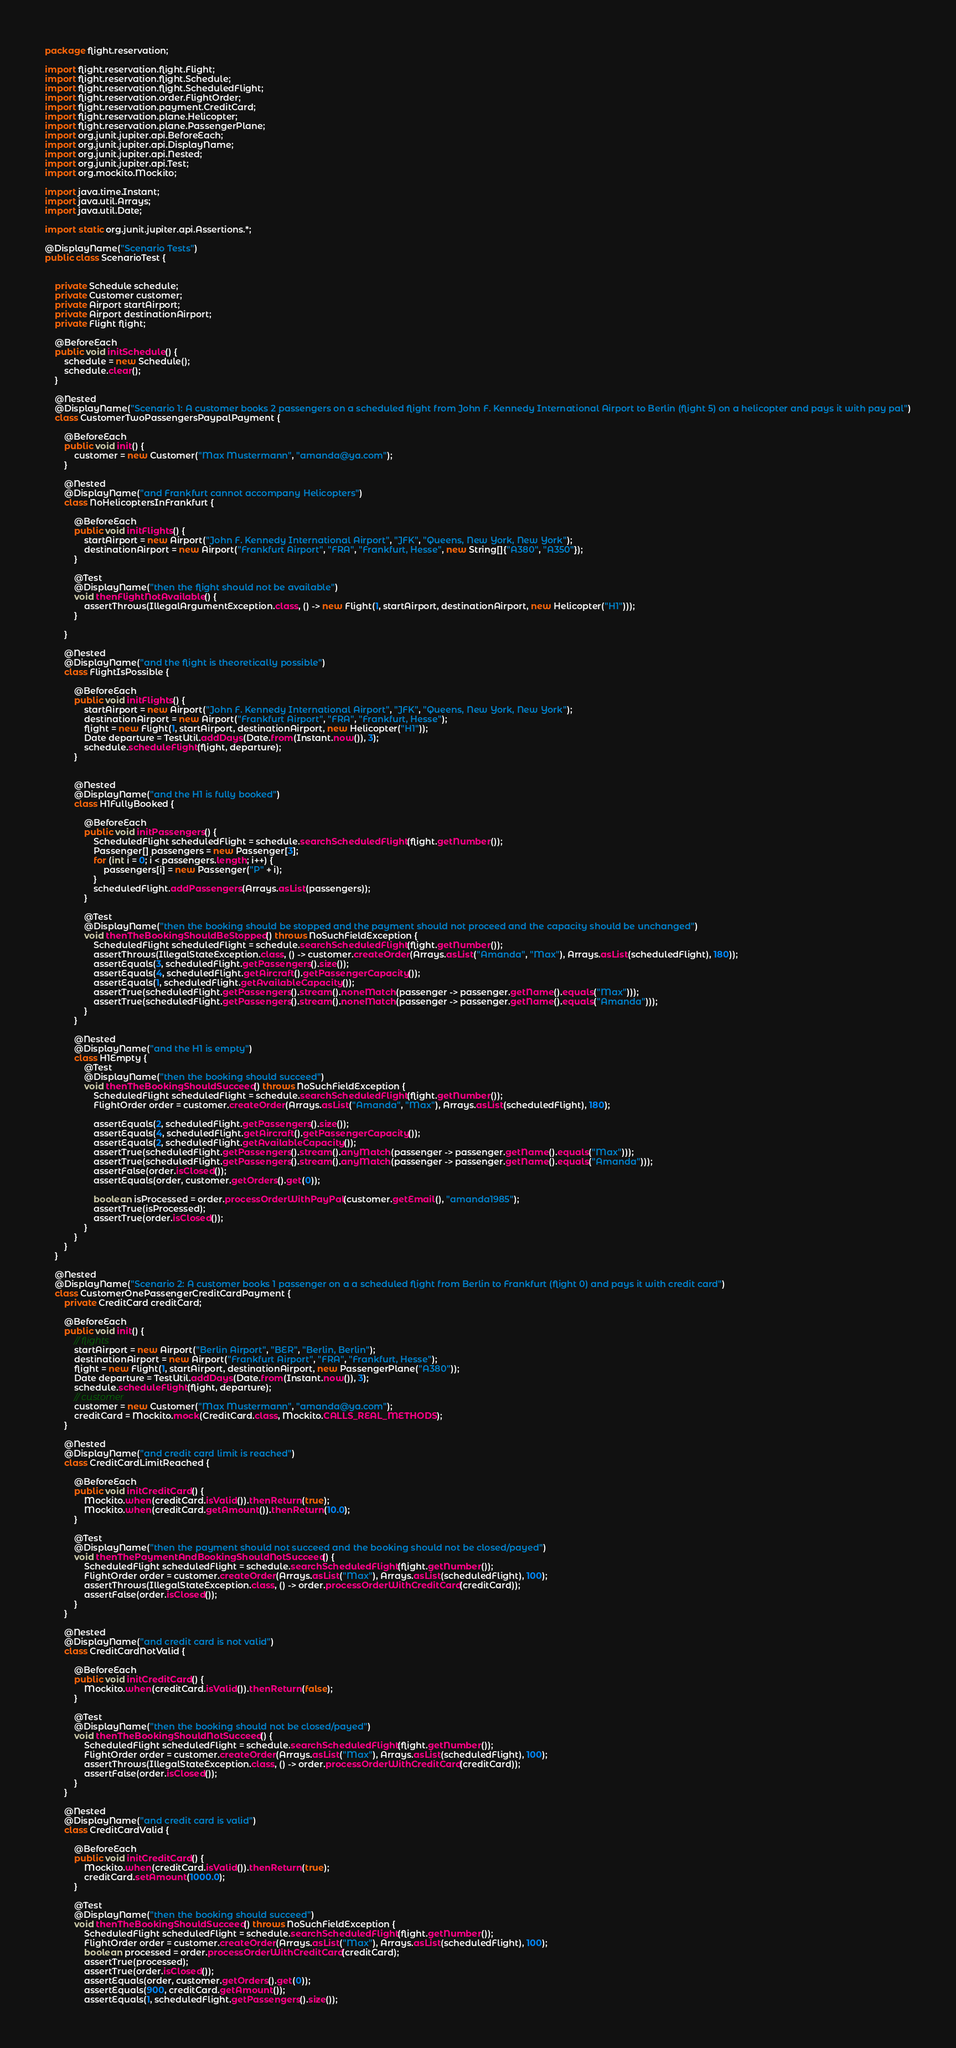<code> <loc_0><loc_0><loc_500><loc_500><_Java_>package flight.reservation;

import flight.reservation.flight.Flight;
import flight.reservation.flight.Schedule;
import flight.reservation.flight.ScheduledFlight;
import flight.reservation.order.FlightOrder;
import flight.reservation.payment.CreditCard;
import flight.reservation.plane.Helicopter;
import flight.reservation.plane.PassengerPlane;
import org.junit.jupiter.api.BeforeEach;
import org.junit.jupiter.api.DisplayName;
import org.junit.jupiter.api.Nested;
import org.junit.jupiter.api.Test;
import org.mockito.Mockito;

import java.time.Instant;
import java.util.Arrays;
import java.util.Date;

import static org.junit.jupiter.api.Assertions.*;

@DisplayName("Scenario Tests")
public class ScenarioTest {


    private Schedule schedule;
    private Customer customer;
    private Airport startAirport;
    private Airport destinationAirport;
    private Flight flight;

    @BeforeEach
    public void initSchedule() {
        schedule = new Schedule();
        schedule.clear();
    }

    @Nested
    @DisplayName("Scenario 1: A customer books 2 passengers on a scheduled flight from John F. Kennedy International Airport to Berlin (flight 5) on a helicopter and pays it with pay pal")
    class CustomerTwoPassengersPaypalPayment {

        @BeforeEach
        public void init() {
            customer = new Customer("Max Mustermann", "amanda@ya.com");
        }

        @Nested
        @DisplayName("and Frankfurt cannot accompany Helicopters")
        class NoHelicoptersInFrankfurt {

            @BeforeEach
            public void initFlights() {
                startAirport = new Airport("John F. Kennedy International Airport", "JFK", "Queens, New York, New York");
                destinationAirport = new Airport("Frankfurt Airport", "FRA", "Frankfurt, Hesse", new String[]{"A380", "A350"});
            }

            @Test
            @DisplayName("then the flight should not be available")
            void thenFlightNotAvailable() {
                assertThrows(IllegalArgumentException.class, () -> new Flight(1, startAirport, destinationAirport, new Helicopter("H1")));
            }

        }

        @Nested
        @DisplayName("and the flight is theoretically possible")
        class FlightIsPossible {

            @BeforeEach
            public void initFlights() {
                startAirport = new Airport("John F. Kennedy International Airport", "JFK", "Queens, New York, New York");
                destinationAirport = new Airport("Frankfurt Airport", "FRA", "Frankfurt, Hesse");
                flight = new Flight(1, startAirport, destinationAirport, new Helicopter("H1"));
                Date departure = TestUtil.addDays(Date.from(Instant.now()), 3);
                schedule.scheduleFlight(flight, departure);
            }


            @Nested
            @DisplayName("and the H1 is fully booked")
            class H1FullyBooked {

                @BeforeEach
                public void initPassengers() {
                    ScheduledFlight scheduledFlight = schedule.searchScheduledFlight(flight.getNumber());
                    Passenger[] passengers = new Passenger[3];
                    for (int i = 0; i < passengers.length; i++) {
                        passengers[i] = new Passenger("P" + i);
                    }
                    scheduledFlight.addPassengers(Arrays.asList(passengers));
                }

                @Test
                @DisplayName("then the booking should be stopped and the payment should not proceed and the capacity should be unchanged")
                void thenTheBookingShouldBeStopped() throws NoSuchFieldException {
                    ScheduledFlight scheduledFlight = schedule.searchScheduledFlight(flight.getNumber());
                    assertThrows(IllegalStateException.class, () -> customer.createOrder(Arrays.asList("Amanda", "Max"), Arrays.asList(scheduledFlight), 180));
                    assertEquals(3, scheduledFlight.getPassengers().size());
                    assertEquals(4, scheduledFlight.getAircraft().getPassengerCapacity());
                    assertEquals(1, scheduledFlight.getAvailableCapacity());
                    assertTrue(scheduledFlight.getPassengers().stream().noneMatch(passenger -> passenger.getName().equals("Max")));
                    assertTrue(scheduledFlight.getPassengers().stream().noneMatch(passenger -> passenger.getName().equals("Amanda")));
                }
            }

            @Nested
            @DisplayName("and the H1 is empty")
            class H1Empty {
                @Test
                @DisplayName("then the booking should succeed")
                void thenTheBookingShouldSucceed() throws NoSuchFieldException {
                    ScheduledFlight scheduledFlight = schedule.searchScheduledFlight(flight.getNumber());
                    FlightOrder order = customer.createOrder(Arrays.asList("Amanda", "Max"), Arrays.asList(scheduledFlight), 180);

                    assertEquals(2, scheduledFlight.getPassengers().size());
                    assertEquals(4, scheduledFlight.getAircraft().getPassengerCapacity());
                    assertEquals(2, scheduledFlight.getAvailableCapacity());
                    assertTrue(scheduledFlight.getPassengers().stream().anyMatch(passenger -> passenger.getName().equals("Max")));
                    assertTrue(scheduledFlight.getPassengers().stream().anyMatch(passenger -> passenger.getName().equals("Amanda")));
                    assertFalse(order.isClosed());
                    assertEquals(order, customer.getOrders().get(0));

                    boolean isProcessed = order.processOrderWithPayPal(customer.getEmail(), "amanda1985");
                    assertTrue(isProcessed);
                    assertTrue(order.isClosed());
                }
            }
        }
    }

    @Nested
    @DisplayName("Scenario 2: A customer books 1 passenger on a a scheduled flight from Berlin to Frankfurt (flight 0) and pays it with credit card")
    class CustomerOnePassengerCreditCardPayment {
        private CreditCard creditCard;

        @BeforeEach
        public void init() {
            // flights
            startAirport = new Airport("Berlin Airport", "BER", "Berlin, Berlin");
            destinationAirport = new Airport("Frankfurt Airport", "FRA", "Frankfurt, Hesse");
            flight = new Flight(1, startAirport, destinationAirport, new PassengerPlane("A380"));
            Date departure = TestUtil.addDays(Date.from(Instant.now()), 3);
            schedule.scheduleFlight(flight, departure);
            // customer
            customer = new Customer("Max Mustermann", "amanda@ya.com");
            creditCard = Mockito.mock(CreditCard.class, Mockito.CALLS_REAL_METHODS);
        }

        @Nested
        @DisplayName("and credit card limit is reached")
        class CreditCardLimitReached {

            @BeforeEach
            public void initCreditCard() {
                Mockito.when(creditCard.isValid()).thenReturn(true);
                Mockito.when(creditCard.getAmount()).thenReturn(10.0);
            }

            @Test
            @DisplayName("then the payment should not succeed and the booking should not be closed/payed")
            void thenThePaymentAndBookingShouldNotSucceed() {
                ScheduledFlight scheduledFlight = schedule.searchScheduledFlight(flight.getNumber());
                FlightOrder order = customer.createOrder(Arrays.asList("Max"), Arrays.asList(scheduledFlight), 100);
                assertThrows(IllegalStateException.class, () -> order.processOrderWithCreditCard(creditCard));
                assertFalse(order.isClosed());
            }
        }

        @Nested
        @DisplayName("and credit card is not valid")
        class CreditCardNotValid {

            @BeforeEach
            public void initCreditCard() {
                Mockito.when(creditCard.isValid()).thenReturn(false);
            }

            @Test
            @DisplayName("then the booking should not be closed/payed")
            void thenTheBookingShouldNotSucceed() {
                ScheduledFlight scheduledFlight = schedule.searchScheduledFlight(flight.getNumber());
                FlightOrder order = customer.createOrder(Arrays.asList("Max"), Arrays.asList(scheduledFlight), 100);
                assertThrows(IllegalStateException.class, () -> order.processOrderWithCreditCard(creditCard));
                assertFalse(order.isClosed());
            }
        }

        @Nested
        @DisplayName("and credit card is valid")
        class CreditCardValid {

            @BeforeEach
            public void initCreditCard() {
                Mockito.when(creditCard.isValid()).thenReturn(true);
                creditCard.setAmount(1000.0);
            }

            @Test
            @DisplayName("then the booking should succeed")
            void thenTheBookingShouldSucceed() throws NoSuchFieldException {
                ScheduledFlight scheduledFlight = schedule.searchScheduledFlight(flight.getNumber());
                FlightOrder order = customer.createOrder(Arrays.asList("Max"), Arrays.asList(scheduledFlight), 100);
                boolean processed = order.processOrderWithCreditCard(creditCard);
                assertTrue(processed);
                assertTrue(order.isClosed());
                assertEquals(order, customer.getOrders().get(0));
                assertEquals(900, creditCard.getAmount());
                assertEquals(1, scheduledFlight.getPassengers().size());</code> 